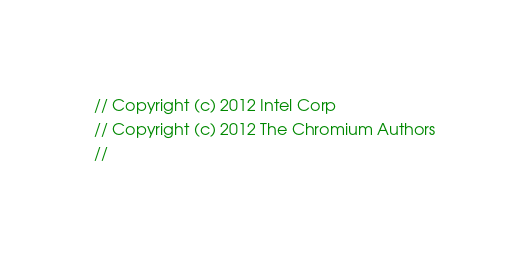Convert code to text. <code><loc_0><loc_0><loc_500><loc_500><_ObjectiveC_>// Copyright (c) 2012 Intel Corp
// Copyright (c) 2012 The Chromium Authors
//</code> 